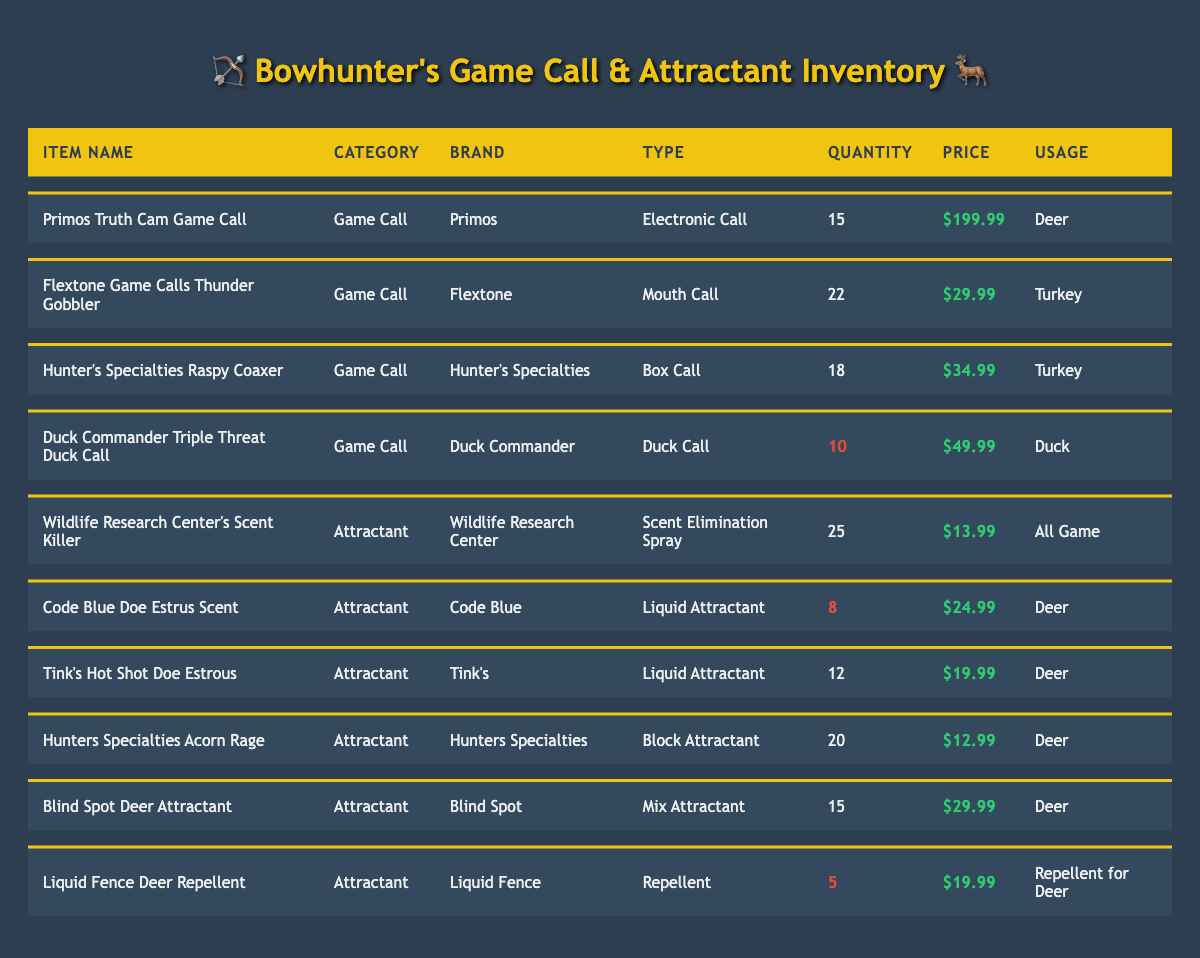What is the total available quantity of game calls? To find the total available quantity of game calls, I will add the quantities of each game call listed in the inventory. The quantities are: 15 (Primos Truth Cam Game Call) + 22 (Flextone Game Calls Thunder Gobbler) + 18 (Hunter's Specialties Raspy Coaxer) + 10 (Duck Commander Triple Threat Duck Call) = 65.
Answer: 65 Which attractant has the lowest available quantity? By examining the available quantities of all the attractants, I see that the quantities are 25 (Wildlife Research Center's Scent Killer), 8 (Code Blue Doe Estrus Scent), 12 (Tink's Hot Shot Doe Estrous), 20 (Hunters Specialties Acorn Rage), 15 (Blind Spot Deer Attractant), and 5 (Liquid Fence Deer Repellent). The lowest quantity is 5.
Answer: Liquid Fence Deer Repellent Is the price of the Duck Commander Triple Threat Duck Call greater than $50? The price of the Duck Commander Triple Threat Duck Call is $49.99, which is less than $50. Therefore, the statement is false.
Answer: No What is the average price of all the attractants? To find the average price of the attractants, I will first sum the prices: 13.99 (Scent Killer) + 24.99 (Code Blue Doe Estrus) + 19.99 (Tink's Hot Shot) + 12.99 (Acorn Rage) + 29.99 (Blind Spot) + 19.99 (Liquid Fence) = 121.94. There are 6 attractants, so the average is 121.94 / 6 = 20.32.
Answer: 20.32 How many game calls are priced above $30? I will check each game call's price against $30. Prices above $30 are: $199.99 (Primos Truth Cam Game Call), $34.99 (Hunter's Specialties Raspy Coaxer), and $49.99 (Duck Commander Triple Threat Duck Call). There are 3 game calls priced above $30.
Answer: 3 Which brand has the most available quantity of products in the inventory? I will count the available quantities per brand: Primos (15), Flextone (22), Hunter's Specialties (18), Duck Commander (10), Wildlife Research Center (25), Code Blue (8), Tink's (12), Hunters Specialties (20), Blind Spot (15), and Liquid Fence (5). The brand with the highest total is Wildlife Research Center with 25 items available.
Answer: Wildlife Research Center What is the total price of available deer attractants? To find this, I will sum the prices of all deer attractants: 13.99 (Scent Killer) + 24.99 (Code Blue Doe Estrus Scent) + 19.99 (Tink's Hot Shot Doe Estrous) + 12.99 (Hunters Specialties Acorn Rage) + 29.99 (Blind Spot Deer Attractant) + 19.99 (Liquid Fence Deer Repellent) = 121.94.
Answer: 121.94 Are there any items available that are designed for use with both deer and turkey? By examining the table, I find that there are no items listed that are designed for both deer and turkey; all items have specific usages. Therefore, the answer is no.
Answer: No 